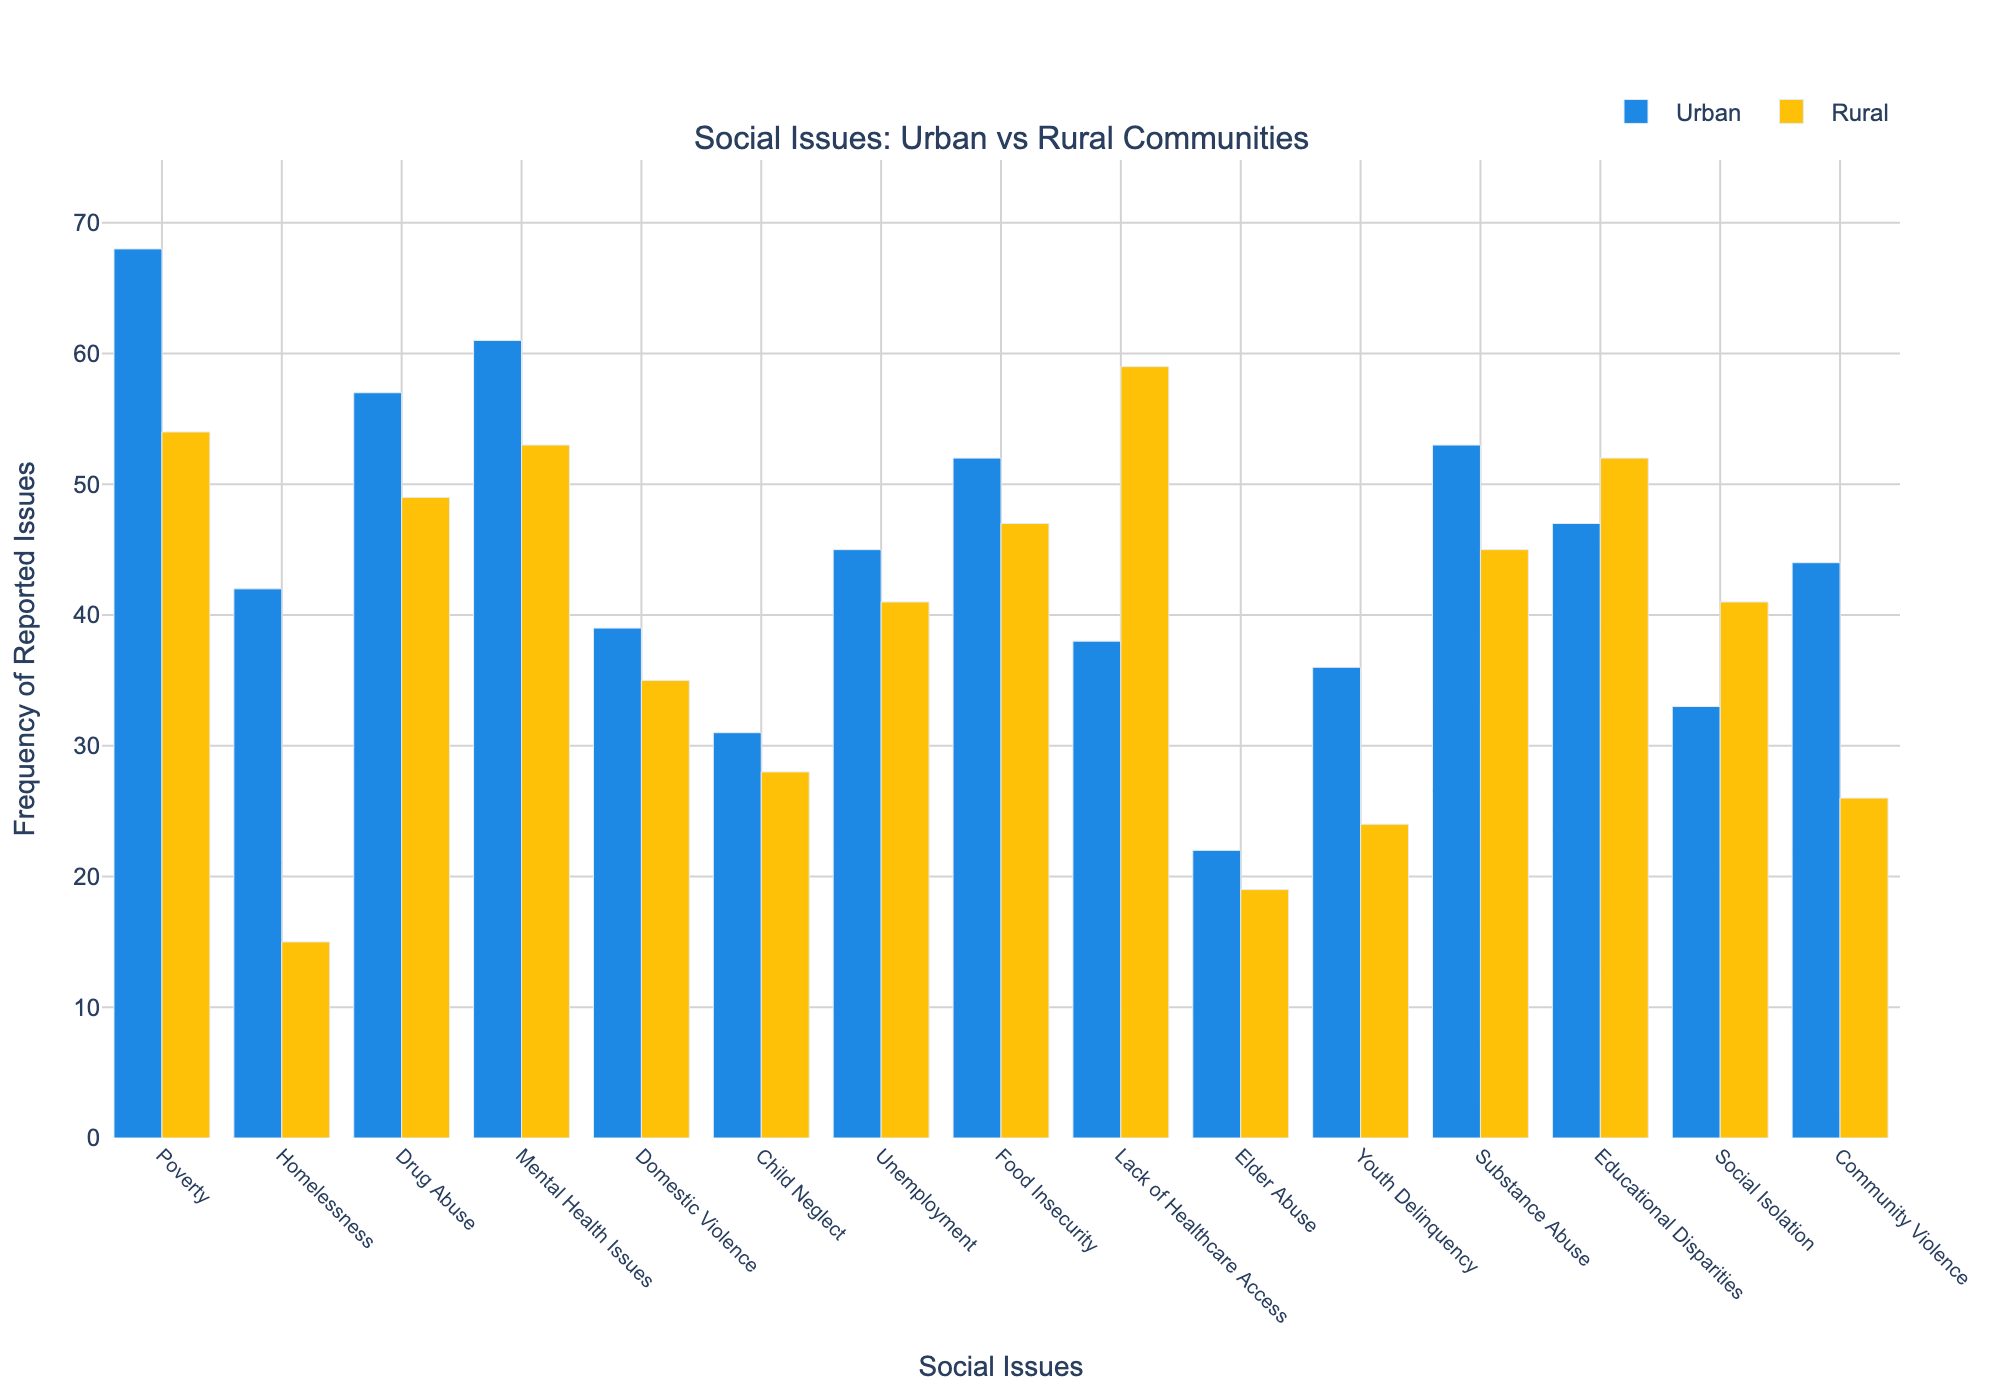How many more cases of homelessness are reported in urban areas compared to rural areas? To find the answer, subtract the number of cases in rural areas from the number of cases in urban areas. For homelessness, the urban number is 42 and the rural number is 15. So, 42 - 15 = 27.
Answer: 27 Which community reports higher cases of lack of healthcare access? Compare the reported cases of lack of healthcare access between urban and rural communities. Urban has 38 cases, while rural has 59 cases. Rural has more cases.
Answer: Rural What is the total number of reported issues for drug abuse in both communities? Add the number of reported cases for drug abuse in urban and rural communities. Urban has 57 cases and rural has 49. So, 57 + 49 = 106.
Answer: 106 Which issue has the smallest difference in reported cases between urban and rural communities? Calculate the difference for each issue and find the smallest one. For Elder Abuse, the difference is abs(22 - 19) = 3. This is the smallest difference among all issues.
Answer: Elder Abuse Between urban and rural communities, which has reported more cases of educational disparities? Compare the cases of educational disparities in urban and rural communities. Urban has 47 cases while rural has 52. Rural has more reported cases.
Answer: Rural For which social issues does urban report more cases than rural? Identify all issues where the urban value is greater than the rural value. These issues are: Poverty, Homelessness, Drug Abuse, Mental Health Issues, Domestic Violence, Child Neglect, Unemployment, Food Insecurity, Elder Abuse, Youth Delinquency, Community Violence.
Answer: Poverty, Homelessness, Drug Abuse, Mental Health Issues, Domestic Violence, Child Neglect, Unemployment, Food Insecurity, Elder Abuse, Youth Delinquency, Community Violence How many more total cases of social isolation are reported in rural areas compared to urban areas? Subtract the number of urban cases from the rural cases for social isolation. Rural has 41 cases and urban has 33. So, 41 - 33 = 8.
Answer: 8 What is the average number of reported cases of child neglect between both communities? Add the number of reported cases in both communities and divide by 2. Urban has 31 cases and rural has 28 cases. (31 + 28) / 2 = 29.5.
Answer: 29.5 If you combine the cases of mental health issues and drug abuse, which community reports more cases? Add the number of cases for mental health issues and drug abuse for both communities and compare. Urban: 61 + 57 = 118, Rural: 53 + 49 = 102. Urban reports more cases.
Answer: Urban What color represents the urban community in the bar chart? Look at the bar chart legend and visual elements. The urban community is represented by blue bars.
Answer: Blue 